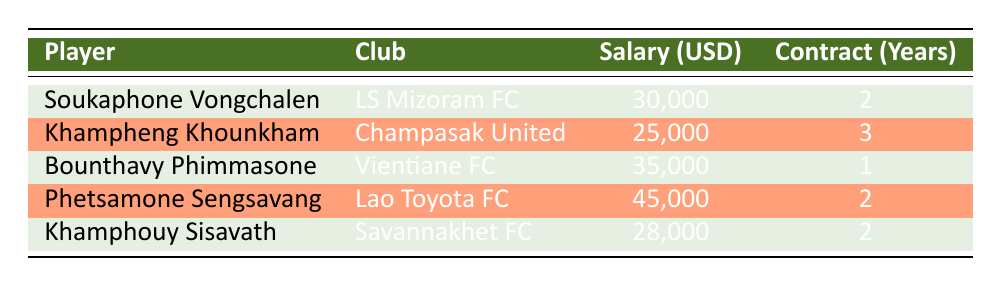What is the salary of Phetsamone Sengsavang? From the table, we can directly find the salary listed next to Phetsamone Sengsavang's name. The salary indicated is 45,000 USD.
Answer: 45,000 USD Which player has the longest contract length? By examining the "Contract (Years)" column, Khampheng Khounkham has a contract length of 3 years, which is the longest among all listed players.
Answer: Khampheng Khounkham What is the total salary of all players combined? To find the total salary, we add the salaries: 30,000 + 25,000 + 35,000 + 45,000 + 28,000 = 163,000 USD.
Answer: 163,000 USD Is Bounthavy Phimmasone's salary higher than Khamphouy Sisavath's? Bounthavy Phimmasone has a salary of 35,000 USD, while Khamphouy Sisavath has a salary of 28,000 USD. Since 35,000 is greater than 28,000, the statement is true.
Answer: Yes What is the average salary of the players with a 2-year contract? The players with a 2-year contract are Soukaphone Vongchalen (30,000), Phetsamone Sengsavang (45,000), and Khamphouy Sisavath (28,000). We add these salaries: 30,000 + 45,000 + 28,000 = 103,000 USD. There are 3 players, so the average salary is 103,000 / 3 ≈ 34,333.33 USD.
Answer: Approximately 34,333.33 USD Which club has the highest-paid player and what is the player's salary? Phetsamone Sengsavang, playing for Lao Toyota FC, has the highest salary listed at 45,000 USD. This is the highest salary in the table.
Answer: Lao Toyota FC, 45,000 USD 